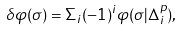<formula> <loc_0><loc_0><loc_500><loc_500>\delta \varphi ( \sigma ) = \Sigma _ { i } ( - 1 ) ^ { i } \varphi ( \sigma | \Delta ^ { p } _ { i } ) ,</formula> 